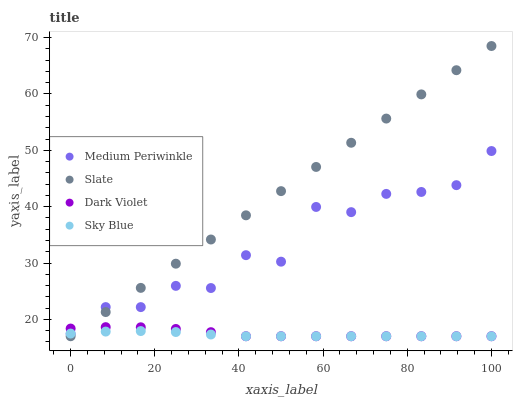Does Sky Blue have the minimum area under the curve?
Answer yes or no. Yes. Does Slate have the maximum area under the curve?
Answer yes or no. Yes. Does Medium Periwinkle have the minimum area under the curve?
Answer yes or no. No. Does Medium Periwinkle have the maximum area under the curve?
Answer yes or no. No. Is Slate the smoothest?
Answer yes or no. Yes. Is Medium Periwinkle the roughest?
Answer yes or no. Yes. Is Medium Periwinkle the smoothest?
Answer yes or no. No. Is Slate the roughest?
Answer yes or no. No. Does Sky Blue have the lowest value?
Answer yes or no. Yes. Does Medium Periwinkle have the lowest value?
Answer yes or no. No. Does Slate have the highest value?
Answer yes or no. Yes. Does Medium Periwinkle have the highest value?
Answer yes or no. No. Does Sky Blue intersect Medium Periwinkle?
Answer yes or no. Yes. Is Sky Blue less than Medium Periwinkle?
Answer yes or no. No. Is Sky Blue greater than Medium Periwinkle?
Answer yes or no. No. 